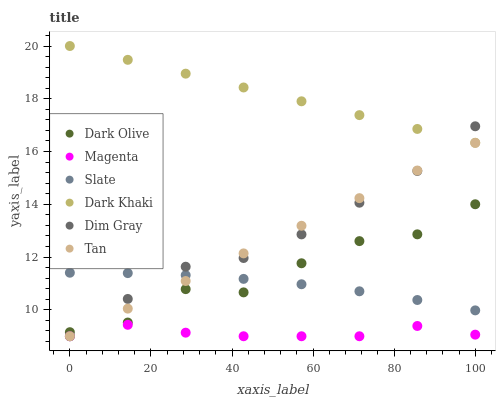Does Magenta have the minimum area under the curve?
Answer yes or no. Yes. Does Dark Khaki have the maximum area under the curve?
Answer yes or no. Yes. Does Slate have the minimum area under the curve?
Answer yes or no. No. Does Slate have the maximum area under the curve?
Answer yes or no. No. Is Tan the smoothest?
Answer yes or no. Yes. Is Dark Olive the roughest?
Answer yes or no. Yes. Is Slate the smoothest?
Answer yes or no. No. Is Slate the roughest?
Answer yes or no. No. Does Dim Gray have the lowest value?
Answer yes or no. Yes. Does Slate have the lowest value?
Answer yes or no. No. Does Dark Khaki have the highest value?
Answer yes or no. Yes. Does Slate have the highest value?
Answer yes or no. No. Is Dark Olive less than Dark Khaki?
Answer yes or no. Yes. Is Dark Olive greater than Magenta?
Answer yes or no. Yes. Does Dark Olive intersect Slate?
Answer yes or no. Yes. Is Dark Olive less than Slate?
Answer yes or no. No. Is Dark Olive greater than Slate?
Answer yes or no. No. Does Dark Olive intersect Dark Khaki?
Answer yes or no. No. 